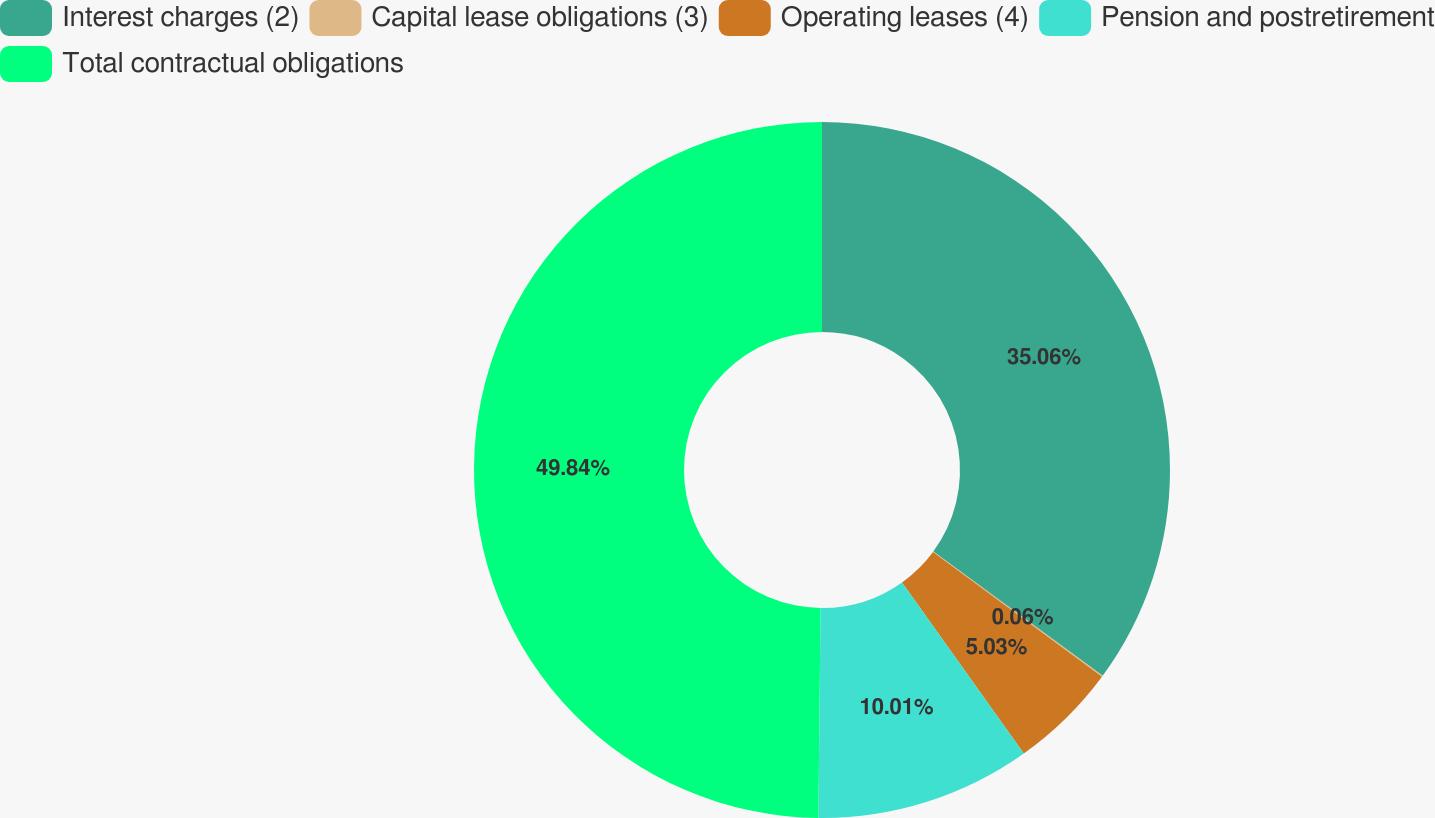<chart> <loc_0><loc_0><loc_500><loc_500><pie_chart><fcel>Interest charges (2)<fcel>Capital lease obligations (3)<fcel>Operating leases (4)<fcel>Pension and postretirement<fcel>Total contractual obligations<nl><fcel>35.06%<fcel>0.06%<fcel>5.03%<fcel>10.01%<fcel>49.83%<nl></chart> 